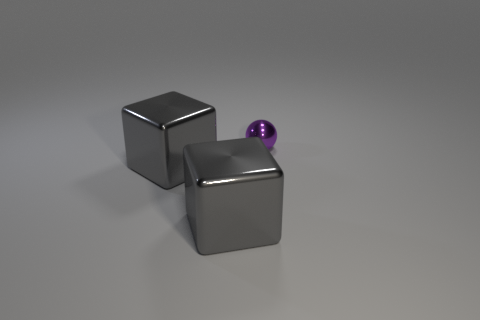Is there any other thing that has the same size as the purple shiny object?
Your answer should be very brief. No. How many purple objects are the same size as the ball?
Your answer should be compact. 0. Are there fewer small purple metal balls than large cyan cylinders?
Provide a short and direct response. No. What number of brown things are shiny objects or large cubes?
Make the answer very short. 0. Is the number of purple things greater than the number of small blue metal cylinders?
Your answer should be compact. Yes. What number of other metallic things are the same color as the small metal object?
Give a very brief answer. 0. What number of rubber objects are cylinders or blocks?
Make the answer very short. 0. What is the material of the small sphere?
Provide a short and direct response. Metal. How many small metal objects are behind the tiny purple metallic object?
Provide a short and direct response. 0. Are there fewer metal blocks behind the purple shiny sphere than big red cylinders?
Your answer should be very brief. No. 